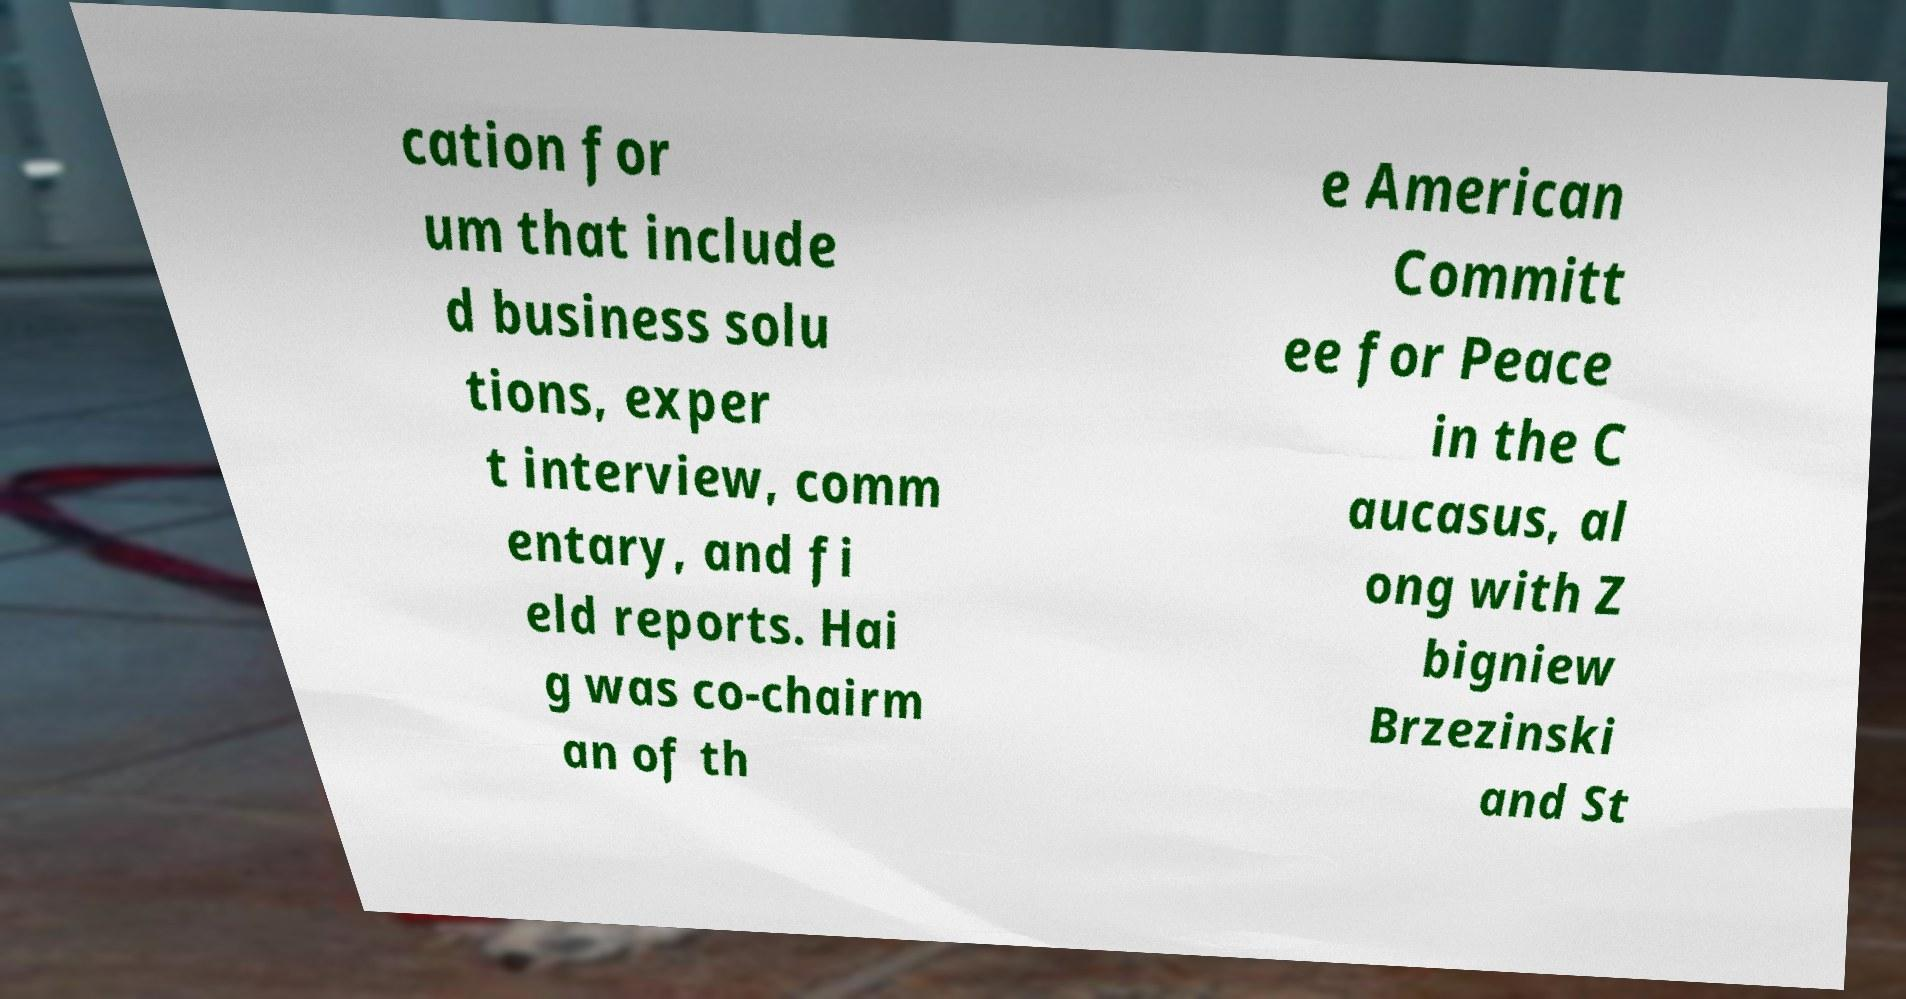Can you accurately transcribe the text from the provided image for me? cation for um that include d business solu tions, exper t interview, comm entary, and fi eld reports. Hai g was co-chairm an of th e American Committ ee for Peace in the C aucasus, al ong with Z bigniew Brzezinski and St 